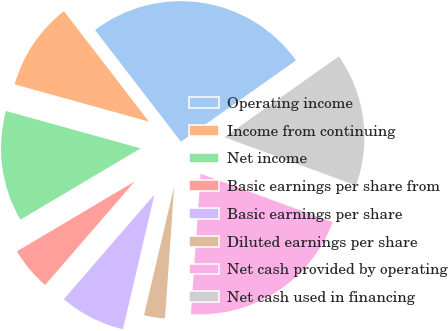Convert chart to OTSL. <chart><loc_0><loc_0><loc_500><loc_500><pie_chart><fcel>Operating income<fcel>Income from continuing<fcel>Net income<fcel>Basic earnings per share from<fcel>Basic earnings per share<fcel>Diluted earnings per share<fcel>Net cash provided by operating<fcel>Net cash used in financing<nl><fcel>25.64%<fcel>10.26%<fcel>12.82%<fcel>5.13%<fcel>7.69%<fcel>2.56%<fcel>20.51%<fcel>15.38%<nl></chart> 